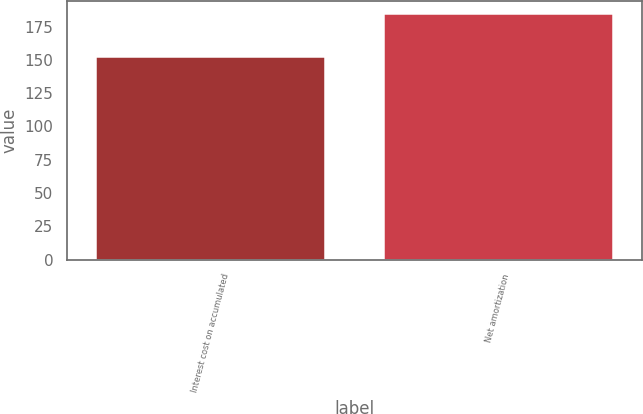Convert chart to OTSL. <chart><loc_0><loc_0><loc_500><loc_500><bar_chart><fcel>Interest cost on accumulated<fcel>Net amortization<nl><fcel>153<fcel>185<nl></chart> 